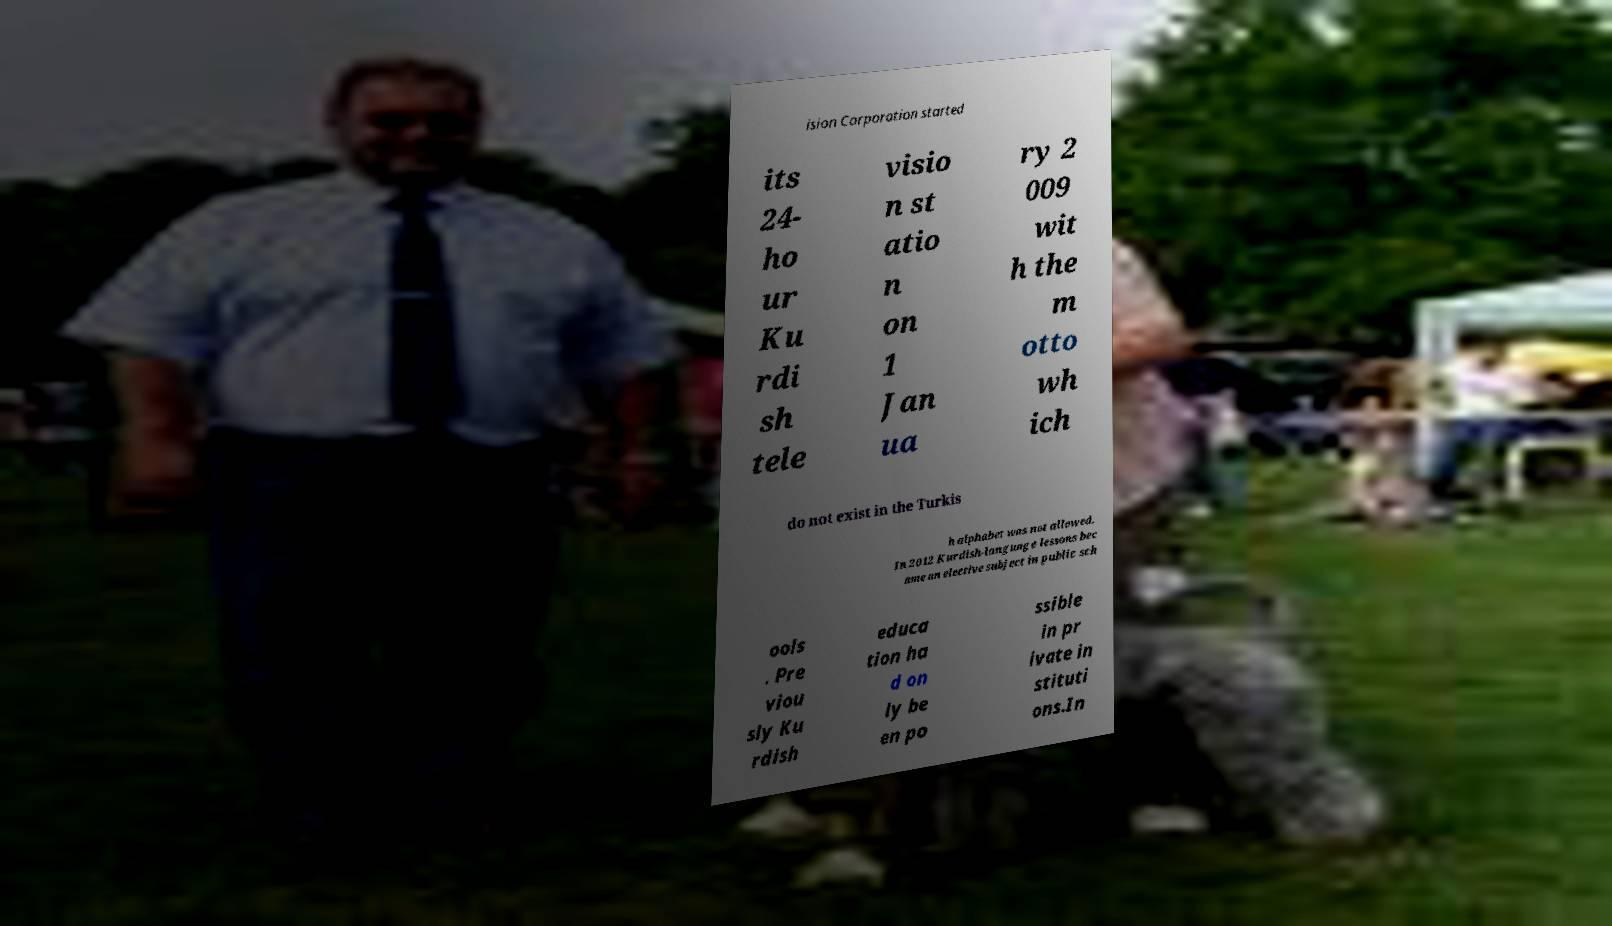Can you accurately transcribe the text from the provided image for me? ision Corporation started its 24- ho ur Ku rdi sh tele visio n st atio n on 1 Jan ua ry 2 009 wit h the m otto wh ich do not exist in the Turkis h alphabet was not allowed. In 2012 Kurdish-language lessons bec ame an elective subject in public sch ools . Pre viou sly Ku rdish educa tion ha d on ly be en po ssible in pr ivate in stituti ons.In 